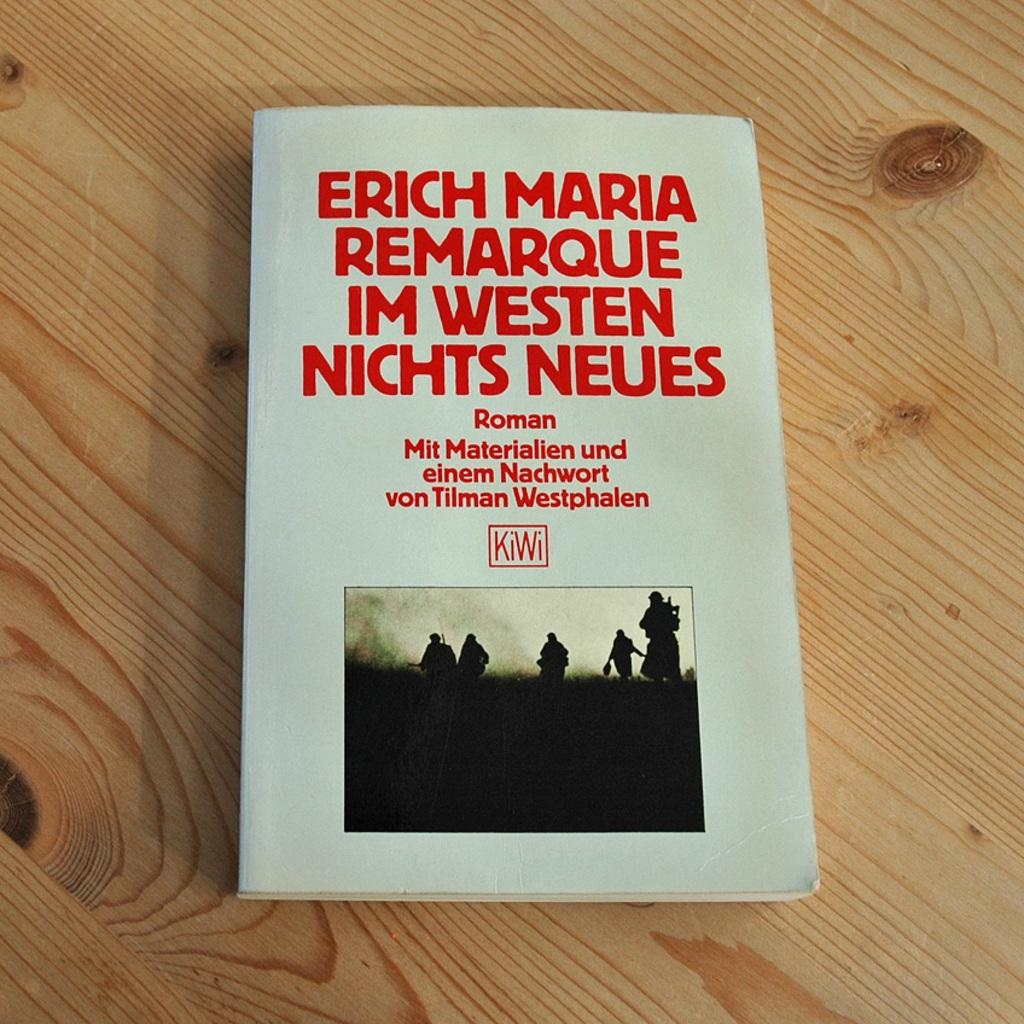<image>
Describe the image concisely. The name of a book is in a foreign language, the publisher of a book is Kiwi. 